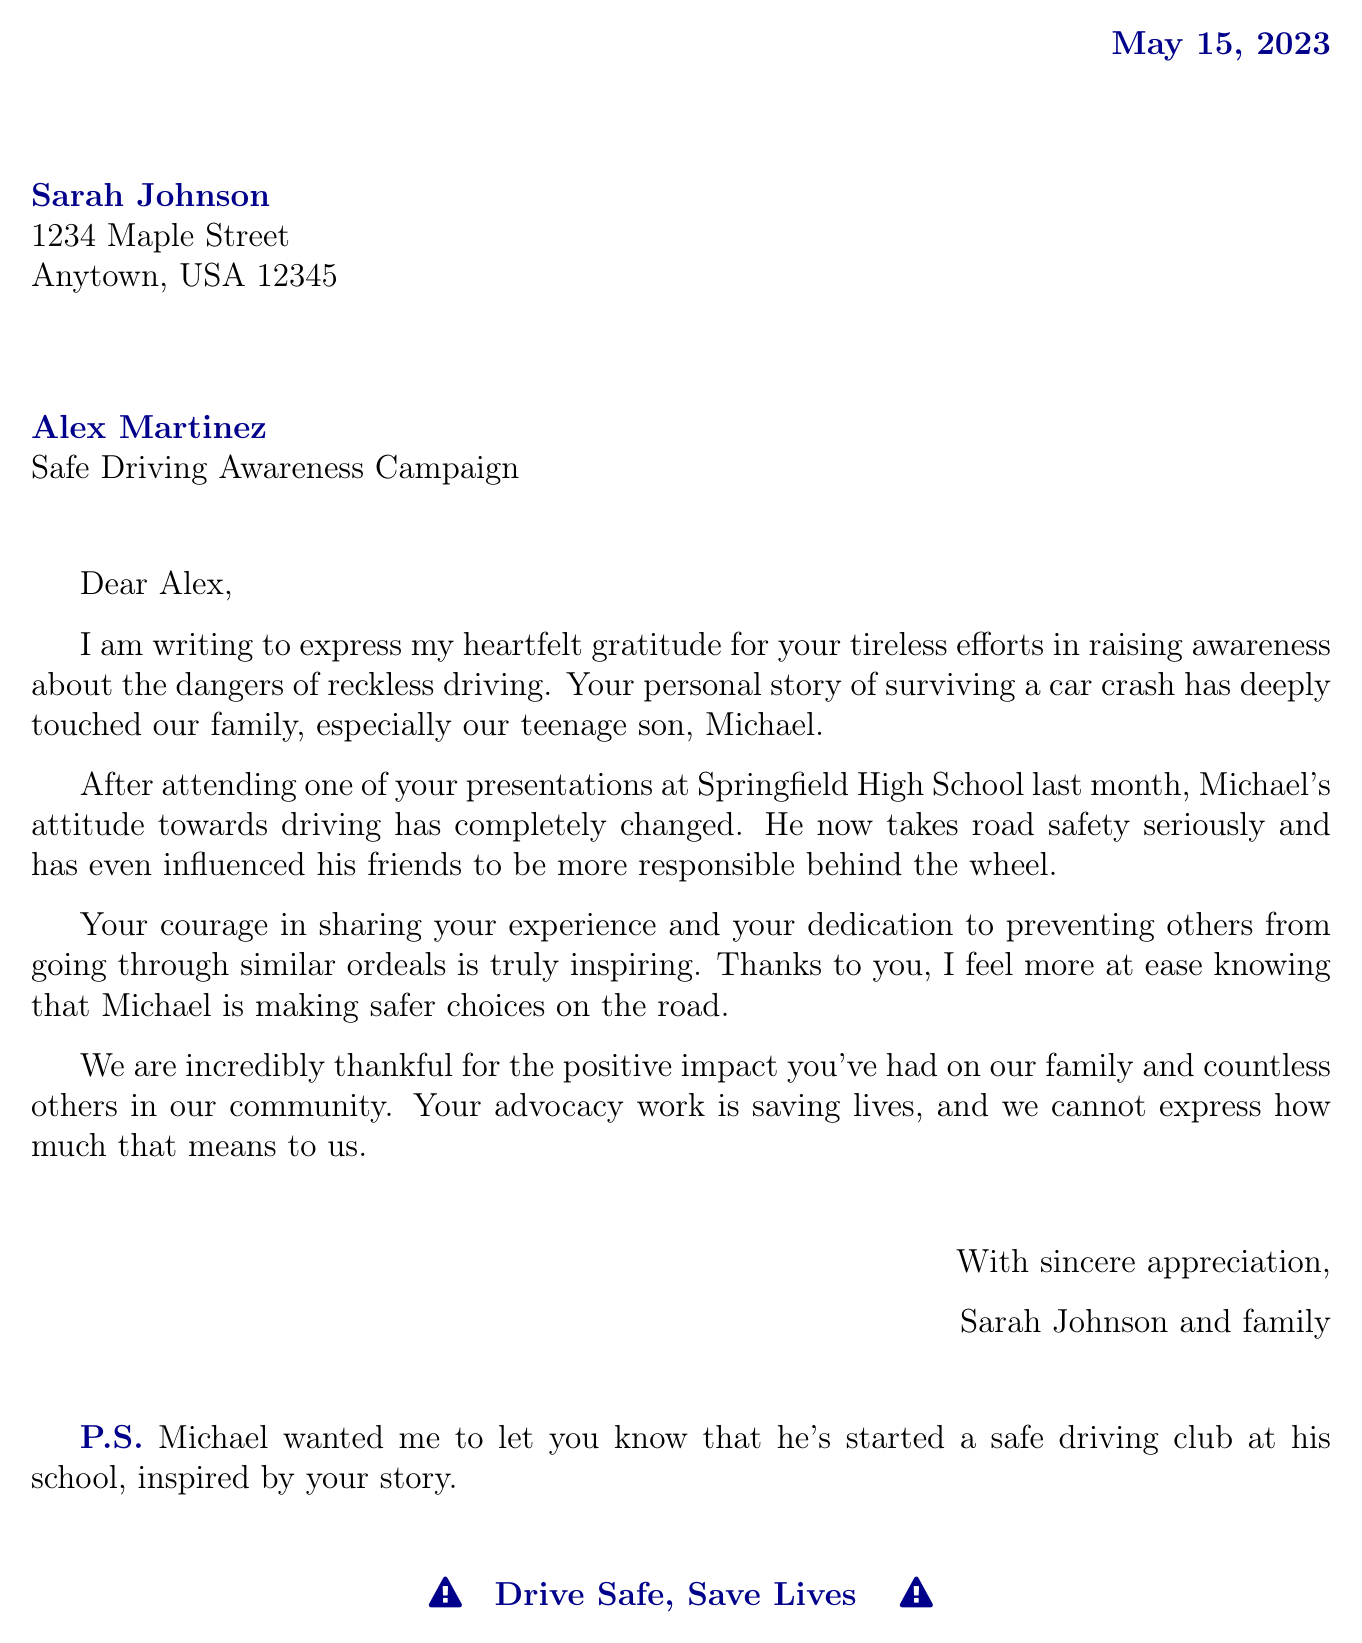What is the sender's name? The sender's name is stated at the beginning of the document.
Answer: Sarah Johnson What is the recipient's organization? The organization of the recipient is mentioned right after their name.
Answer: Safe Driving Awareness Campaign When was the letter written? The date of the letter is displayed at the top of the document.
Answer: May 15, 2023 Who was influenced by the advocacy? The document specifies that a specific person was influenced by the advocacy efforts.
Answer: Michael What has Michael started at his school? The letter mentions an initiative that Michael undertook inspired by the advocacy.
Answer: safe driving club What feeling does Sarah express about Michael's choices? The document describes the sender's emotional response regarding Michael's driving habits.
Answer: more at ease What was the purpose of writing the letter? The sender explains the reason for writing within the letter’s opening sentences.
Answer: express gratitude What main quality of Alex does Sarah highlight? Sarah emphasizes a particular trait of Alex related to their advocacy work.
Answer: courage How has Michael influenced his friends? The letter states how Michael's actions have affected his peers in a specific way.
Answer: be more responsible behind the wheel 